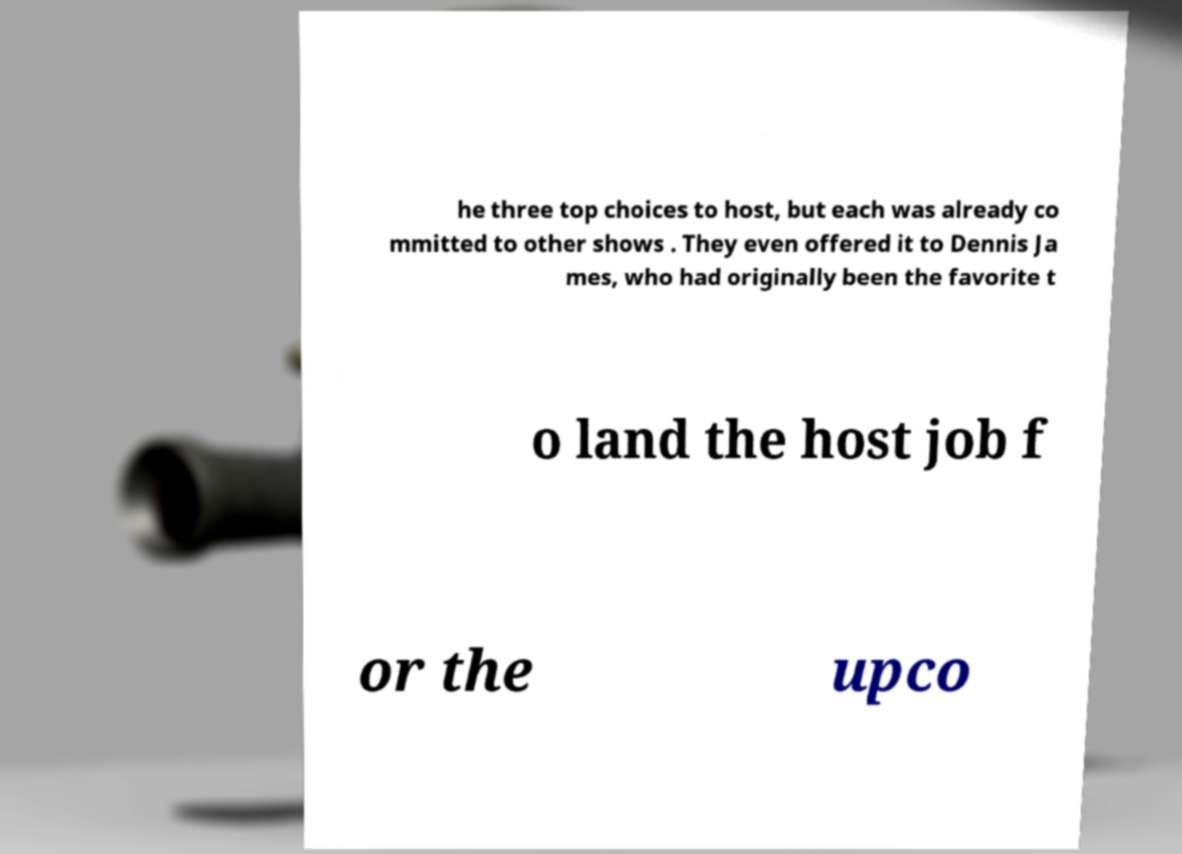Can you read and provide the text displayed in the image?This photo seems to have some interesting text. Can you extract and type it out for me? he three top choices to host, but each was already co mmitted to other shows . They even offered it to Dennis Ja mes, who had originally been the favorite t o land the host job f or the upco 